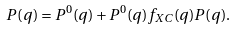<formula> <loc_0><loc_0><loc_500><loc_500>P ( q ) = P ^ { 0 } ( q ) + P ^ { 0 } ( q ) f _ { X C } ( q ) P ( q ) .</formula> 